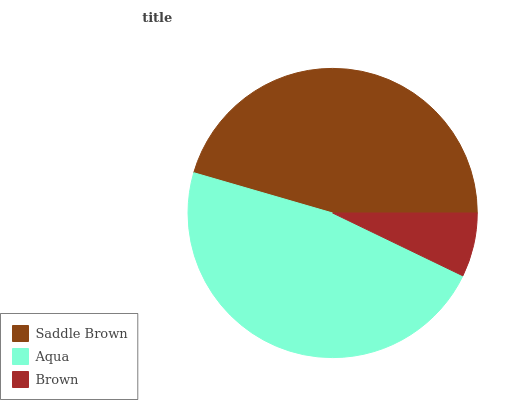Is Brown the minimum?
Answer yes or no. Yes. Is Aqua the maximum?
Answer yes or no. Yes. Is Aqua the minimum?
Answer yes or no. No. Is Brown the maximum?
Answer yes or no. No. Is Aqua greater than Brown?
Answer yes or no. Yes. Is Brown less than Aqua?
Answer yes or no. Yes. Is Brown greater than Aqua?
Answer yes or no. No. Is Aqua less than Brown?
Answer yes or no. No. Is Saddle Brown the high median?
Answer yes or no. Yes. Is Saddle Brown the low median?
Answer yes or no. Yes. Is Brown the high median?
Answer yes or no. No. Is Aqua the low median?
Answer yes or no. No. 